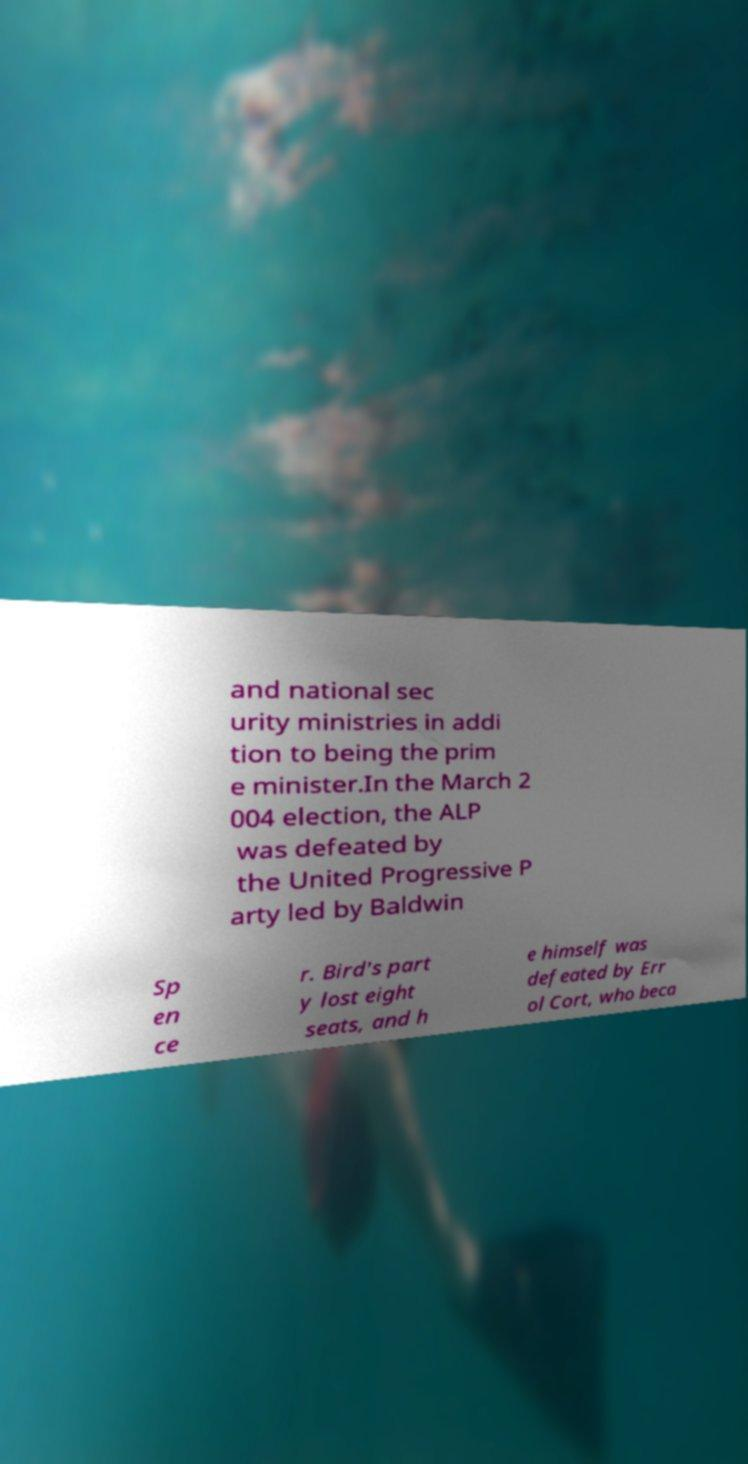Could you extract and type out the text from this image? and national sec urity ministries in addi tion to being the prim e minister.In the March 2 004 election, the ALP was defeated by the United Progressive P arty led by Baldwin Sp en ce r. Bird's part y lost eight seats, and h e himself was defeated by Err ol Cort, who beca 